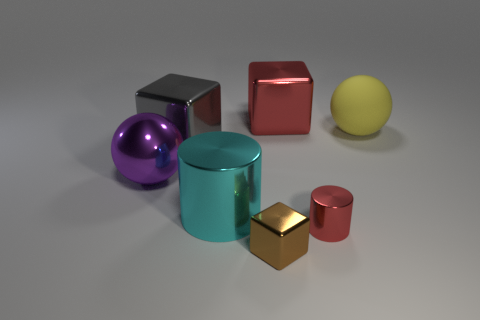What is the color of the tiny metal thing that is on the left side of the red shiny thing that is in front of the big gray thing?
Ensure brevity in your answer.  Brown. Is there a shiny object that has the same size as the brown cube?
Your answer should be very brief. Yes. There is a big block in front of the large object on the right side of the shiny object that is behind the large gray shiny block; what is its material?
Provide a succinct answer. Metal. There is a red metal thing that is left of the red cylinder; how many large yellow rubber things are on the left side of it?
Make the answer very short. 0. Is the size of the red object behind the purple shiny thing the same as the big cyan metal object?
Give a very brief answer. Yes. What number of big cyan things are the same shape as the tiny brown shiny object?
Your response must be concise. 0. The purple thing is what shape?
Offer a very short reply. Sphere. Are there an equal number of large yellow things that are right of the yellow object and objects?
Offer a terse response. No. Are there any other things that have the same material as the big cyan object?
Your answer should be very brief. Yes. Are the large ball left of the large yellow matte ball and the yellow thing made of the same material?
Your response must be concise. No. 